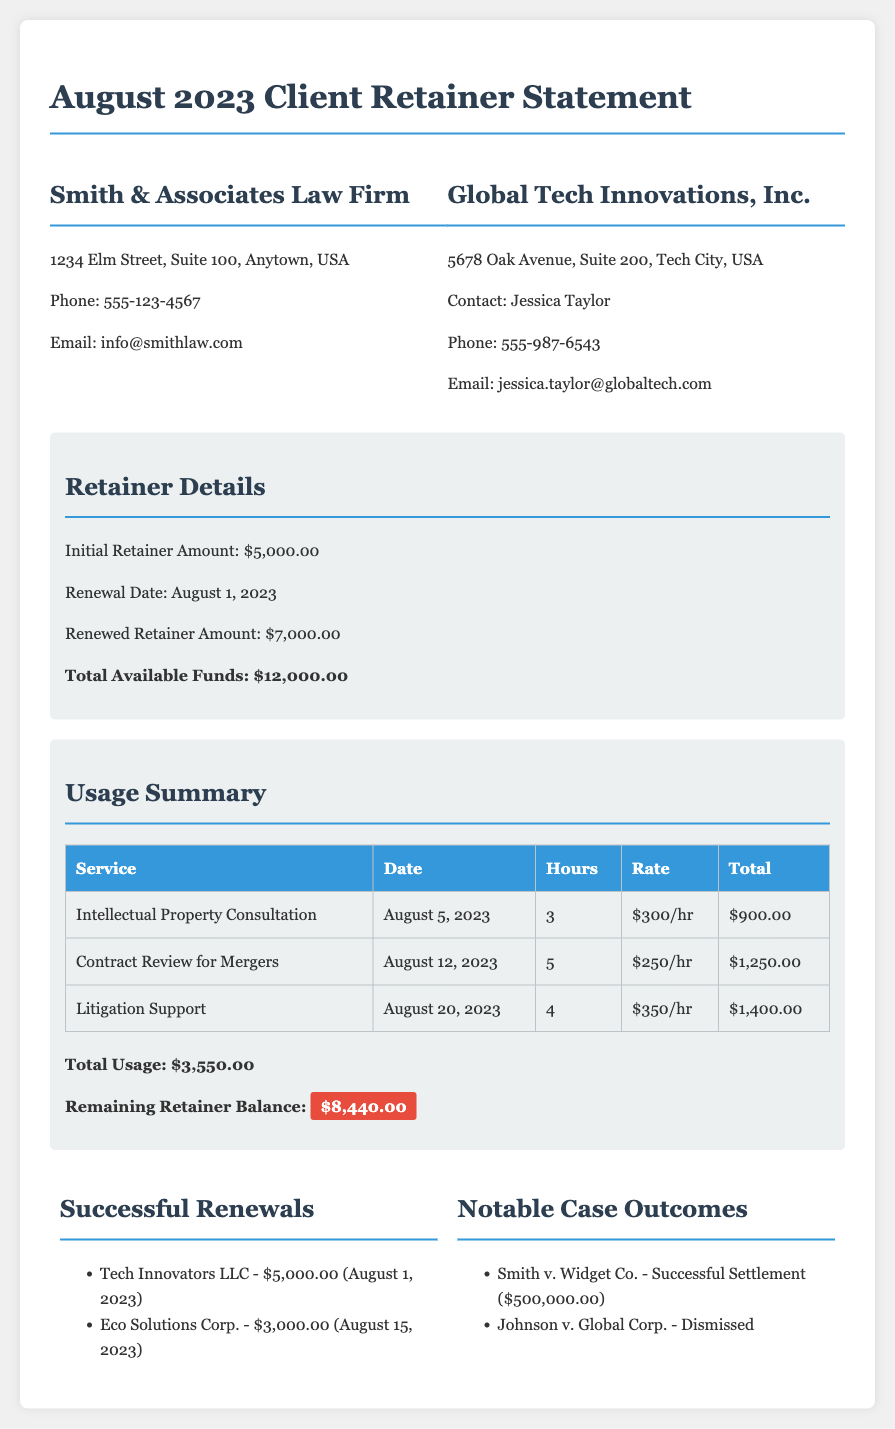What is the initial retainer amount? The initial retainer amount stated in the document is $5,000.00.
Answer: $5,000.00 What is the renewed retainer amount? The renewed retainer amount mentioned is $7,000.00, which is highlighted in the retainer details section.
Answer: $7,000.00 What is the total available funds? The total available funds calculated from the initial and renewed amounts is $12,000.00.
Answer: $12,000.00 How much was used from the retainer? The usage summary indicates that a total of $3,550.00 was utilized from the retainer funds.
Answer: $3,550.00 What is the remaining retainer balance? The document clearly states that the remaining retainer balance is $8,440.00.
Answer: $8,440.00 When was the renewal date? The renewal date for the retainer is specified as August 1, 2023.
Answer: August 1, 2023 What is the total amount of successful renewals? The successful renewals total is $8,000.00, derived from the two figures listed under successful renewals.
Answer: $8,000.00 What was the notable case outcome mentioned? One notable case outcome mentioned is a successful settlement of Smith v. Widget Co. for $500,000.00.
Answer: Successful Settlement ($500,000.00) How many hours were billed for litigation support? The number of hours billed for litigation support is 4, as noted in the usage summary.
Answer: 4 What is the rate for contract review for mergers? The rate specified for the contract review service is $250 per hour.
Answer: $250/hr 